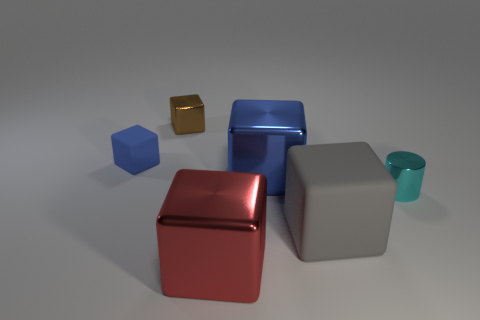Subtract all large matte blocks. How many blocks are left? 4 Subtract all gray cubes. How many cubes are left? 4 Subtract 2 blocks. How many blocks are left? 3 Subtract all purple blocks. Subtract all red cylinders. How many blocks are left? 5 Add 1 matte cubes. How many objects exist? 7 Subtract all cylinders. How many objects are left? 5 Subtract all small red cylinders. Subtract all blue metal cubes. How many objects are left? 5 Add 6 tiny blue blocks. How many tiny blue blocks are left? 7 Add 5 tiny metallic things. How many tiny metallic things exist? 7 Subtract 0 brown spheres. How many objects are left? 6 